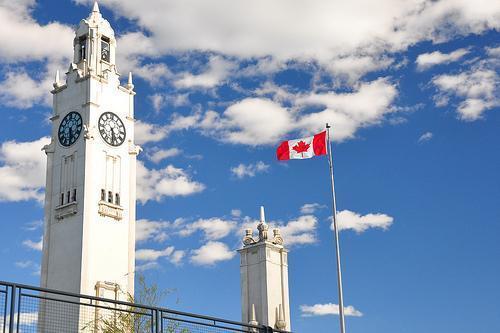How many flags are shown?
Give a very brief answer. 1. 